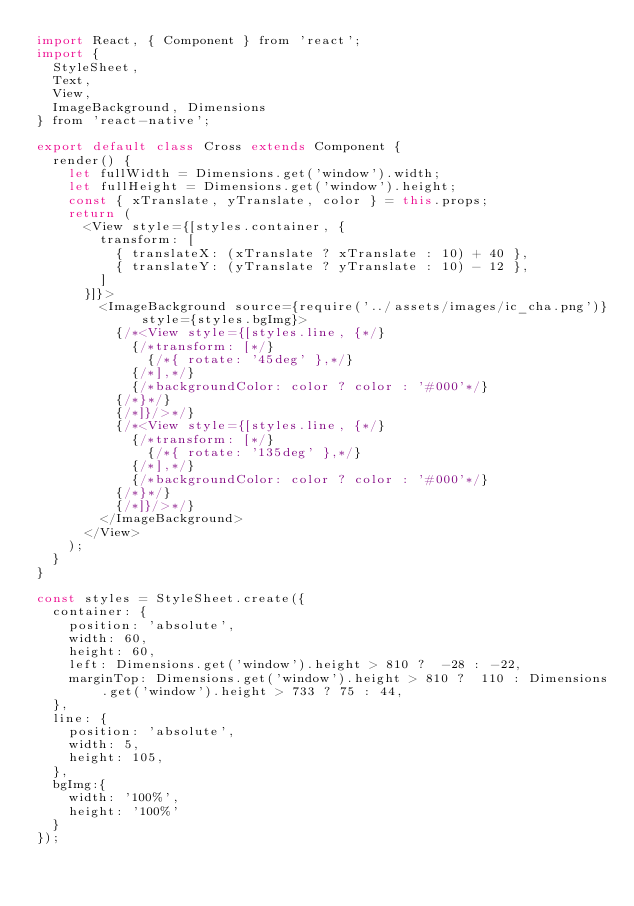<code> <loc_0><loc_0><loc_500><loc_500><_JavaScript_>import React, { Component } from 'react';
import {
  StyleSheet,
  Text,
  View,
  ImageBackground, Dimensions
} from 'react-native';

export default class Cross extends Component {
  render() {
    let fullWidth = Dimensions.get('window').width;
    let fullHeight = Dimensions.get('window').height;
    const { xTranslate, yTranslate, color } = this.props;
    return (
      <View style={[styles.container, {
        transform: [
          { translateX: (xTranslate ? xTranslate : 10) + 40 },
          { translateY: (yTranslate ? yTranslate : 10) - 12 },
        ]
      }]}>
        <ImageBackground source={require('../assets/images/ic_cha.png')} style={styles.bgImg}>
          {/*<View style={[styles.line, {*/}
            {/*transform: [*/}
              {/*{ rotate: '45deg' },*/}
            {/*],*/}
            {/*backgroundColor: color ? color : '#000'*/}
          {/*}*/}
          {/*]}/>*/}
          {/*<View style={[styles.line, {*/}
            {/*transform: [*/}
              {/*{ rotate: '135deg' },*/}
            {/*],*/}
            {/*backgroundColor: color ? color : '#000'*/}
          {/*}*/}
          {/*]}/>*/}
        </ImageBackground>
      </View>
    );
  }
}

const styles = StyleSheet.create({
  container: {
    position: 'absolute',
    width: 60,
    height: 60,
    left: Dimensions.get('window').height > 810 ?  -28 : -22,
    marginTop: Dimensions.get('window').height > 810 ?  110 : Dimensions.get('window').height > 733 ? 75 : 44,
  },
  line: {
    position: 'absolute',
    width: 5,
    height: 105,
  },
  bgImg:{
    width: '100%',
    height: '100%'
  }
});
</code> 